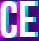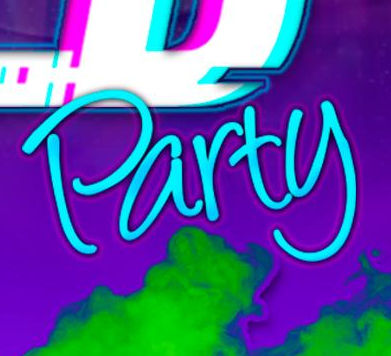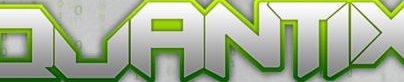Identify the words shown in these images in order, separated by a semicolon. CE; Party; QUANTIX 